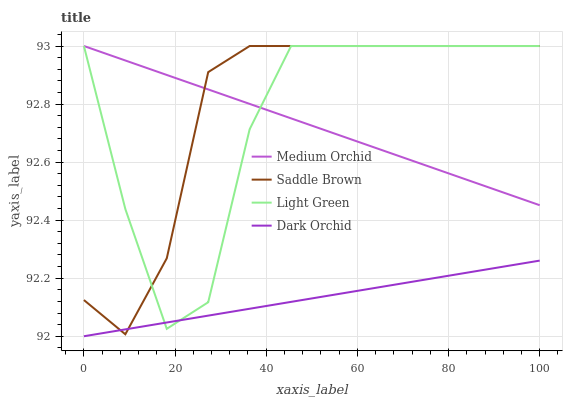Does Dark Orchid have the minimum area under the curve?
Answer yes or no. Yes. Does Saddle Brown have the maximum area under the curve?
Answer yes or no. Yes. Does Medium Orchid have the minimum area under the curve?
Answer yes or no. No. Does Medium Orchid have the maximum area under the curve?
Answer yes or no. No. Is Medium Orchid the smoothest?
Answer yes or no. Yes. Is Light Green the roughest?
Answer yes or no. Yes. Is Saddle Brown the smoothest?
Answer yes or no. No. Is Saddle Brown the roughest?
Answer yes or no. No. Does Dark Orchid have the lowest value?
Answer yes or no. Yes. Does Saddle Brown have the lowest value?
Answer yes or no. No. Does Light Green have the highest value?
Answer yes or no. Yes. Is Dark Orchid less than Medium Orchid?
Answer yes or no. Yes. Is Medium Orchid greater than Dark Orchid?
Answer yes or no. Yes. Does Medium Orchid intersect Saddle Brown?
Answer yes or no. Yes. Is Medium Orchid less than Saddle Brown?
Answer yes or no. No. Is Medium Orchid greater than Saddle Brown?
Answer yes or no. No. Does Dark Orchid intersect Medium Orchid?
Answer yes or no. No. 